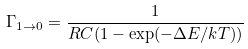Convert formula to latex. <formula><loc_0><loc_0><loc_500><loc_500>\Gamma _ { 1 \rightarrow 0 } = \frac { 1 } { R C ( 1 - \exp ( - \Delta E / k T ) ) }</formula> 